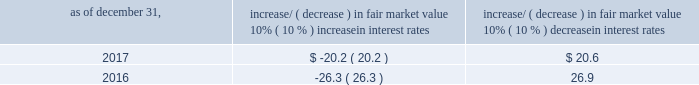Item 7a .
Quantitative and qualitative disclosures about market risk ( amounts in millions ) in the normal course of business , we are exposed to market risks related to interest rates , foreign currency rates and certain balance sheet items .
From time to time , we use derivative instruments , pursuant to established guidelines and policies , to manage some portion of these risks .
Derivative instruments utilized in our hedging activities are viewed as risk management tools and are not used for trading or speculative purposes .
Interest rates our exposure to market risk for changes in interest rates relates primarily to the fair market value and cash flows of our debt obligations .
The majority of our debt ( approximately 94% ( 94 % ) and 93% ( 93 % ) as of december 31 , 2017 and 2016 , respectively ) bears interest at fixed rates .
We do have debt with variable interest rates , but a 10% ( 10 % ) increase or decrease in interest rates would not be material to our interest expense or cash flows .
The fair market value of our debt is sensitive to changes in interest rates , and the impact of a 10% ( 10 % ) change in interest rates is summarized below .
Increase/ ( decrease ) in fair market value as of december 31 , 10% ( 10 % ) increase in interest rates 10% ( 10 % ) decrease in interest rates .
We have used interest rate swaps for risk management purposes to manage our exposure to changes in interest rates .
We did not have any interest rate swaps outstanding as of december 31 , 2017 .
We had $ 791.0 of cash , cash equivalents and marketable securities as of december 31 , 2017 that we generally invest in conservative , short-term bank deposits or securities .
The interest income generated from these investments is subject to both domestic and foreign interest rate movements .
During 2017 and 2016 , we had interest income of $ 19.4 and $ 20.1 , respectively .
Based on our 2017 results , a 100 basis-point increase or decrease in interest rates would affect our interest income by approximately $ 7.9 , assuming that all cash , cash equivalents and marketable securities are impacted in the same manner and balances remain constant from year-end 2017 levels .
Foreign currency rates we are subject to translation and transaction risks related to changes in foreign currency exchange rates .
Since we report revenues and expenses in u.s .
Dollars , changes in exchange rates may either positively or negatively affect our consolidated revenues and expenses ( as expressed in u.s .
Dollars ) from foreign operations .
The foreign currencies that most impacted our results during 2017 included the british pound sterling and , to a lesser extent , brazilian real and south african rand .
Based on 2017 exchange rates and operating results , if the u.s .
Dollar were to strengthen or weaken by 10% ( 10 % ) , we currently estimate operating income would decrease or increase approximately 4% ( 4 % ) , assuming that all currencies are impacted in the same manner and our international revenue and expenses remain constant at 2017 levels .
The functional currency of our foreign operations is generally their respective local currency .
Assets and liabilities are translated at the exchange rates in effect at the balance sheet date , and revenues and expenses are translated at the average exchange rates during the period presented .
The resulting translation adjustments are recorded as a component of accumulated other comprehensive loss , net of tax , in the stockholders 2019 equity section of our consolidated balance sheets .
Our foreign subsidiaries generally collect revenues and pay expenses in their functional currency , mitigating transaction risk .
However , certain subsidiaries may enter into transactions in currencies other than their functional currency .
Assets and liabilities denominated in currencies other than the functional currency are susceptible to movements in foreign currency until final settlement .
Currency transaction gains or losses primarily arising from transactions in currencies other than the functional currency are included in office and general expenses .
We regularly review our foreign exchange exposures that may have a material impact on our business and from time to time use foreign currency forward exchange contracts or other derivative financial instruments to hedge the effects of potential adverse fluctuations in foreign currency exchange rates arising from these exposures .
We do not enter into foreign exchange contracts or other derivatives for speculative purposes. .
What is the growth rate in the interest income in 2017 relative to 2016? 
Computations: ((19.4 - 20.1) / 20.1)
Answer: -0.03483. 